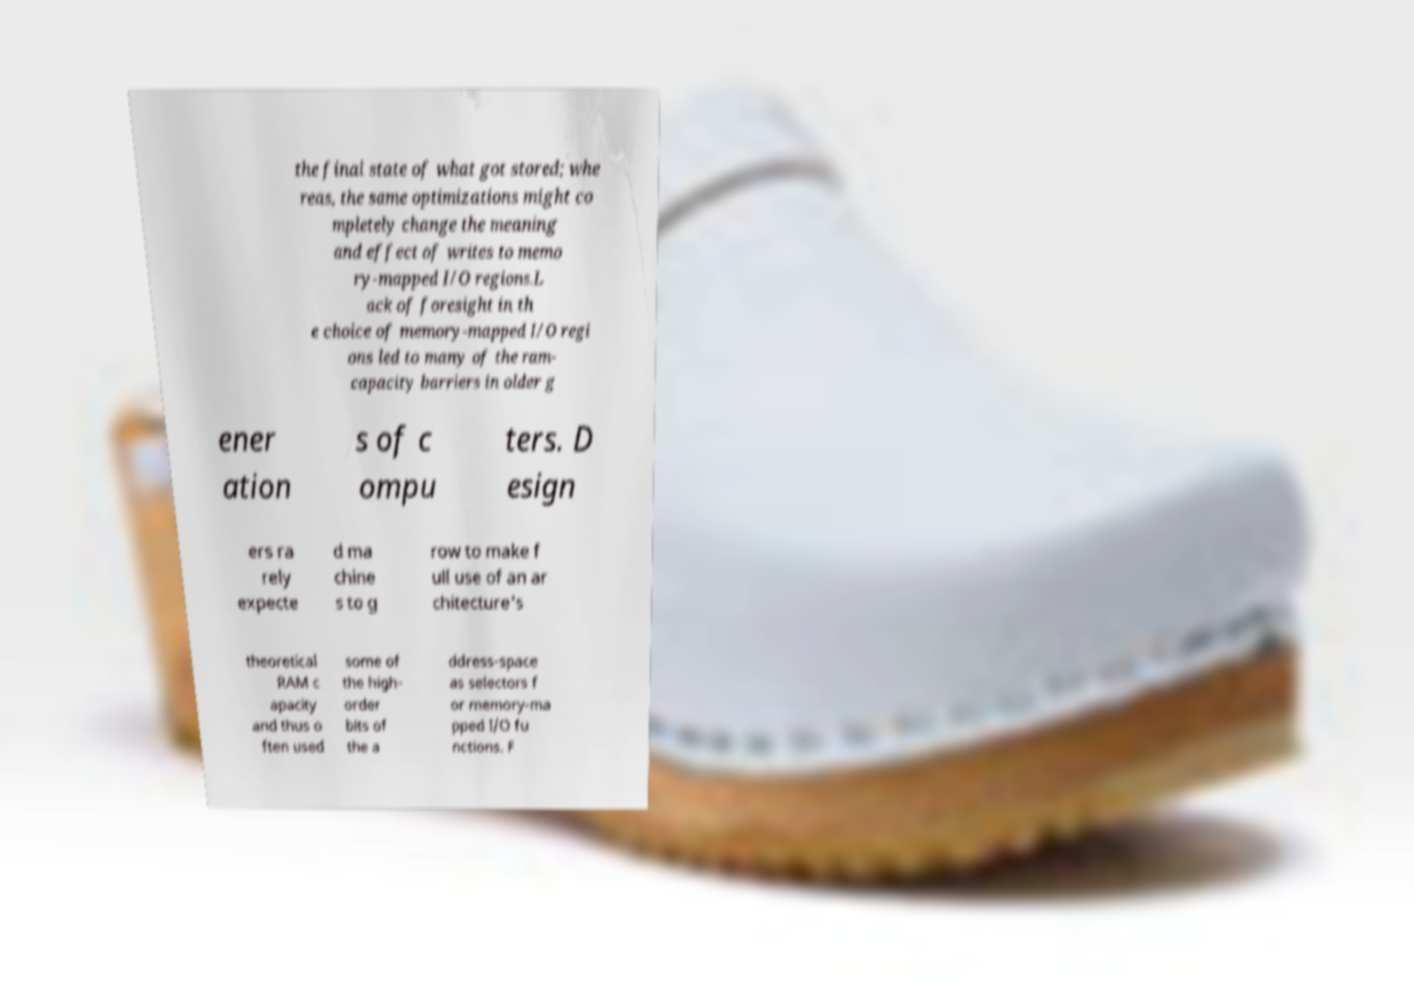Can you accurately transcribe the text from the provided image for me? the final state of what got stored; whe reas, the same optimizations might co mpletely change the meaning and effect of writes to memo ry-mapped I/O regions.L ack of foresight in th e choice of memory-mapped I/O regi ons led to many of the ram- capacity barriers in older g ener ation s of c ompu ters. D esign ers ra rely expecte d ma chine s to g row to make f ull use of an ar chitecture's theoretical RAM c apacity and thus o ften used some of the high- order bits of the a ddress-space as selectors f or memory-ma pped I/O fu nctions. F 